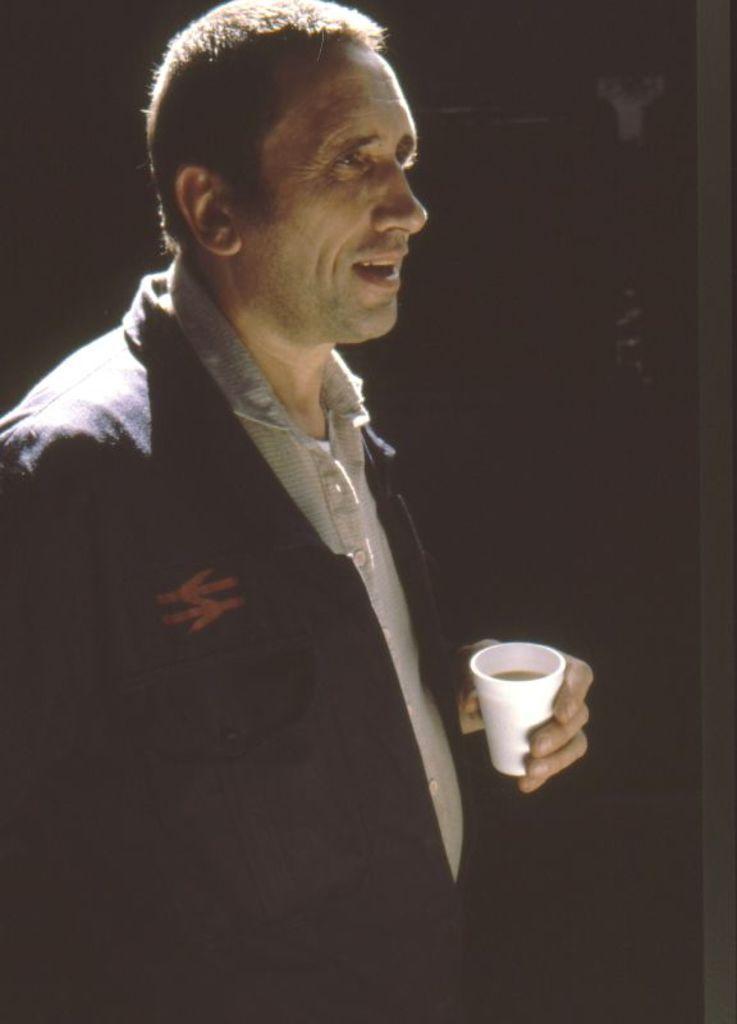In one or two sentences, can you explain what this image depicts? In this image I can see there is a person standing and holding a cup with drink. And at the back it looks like a dark. 